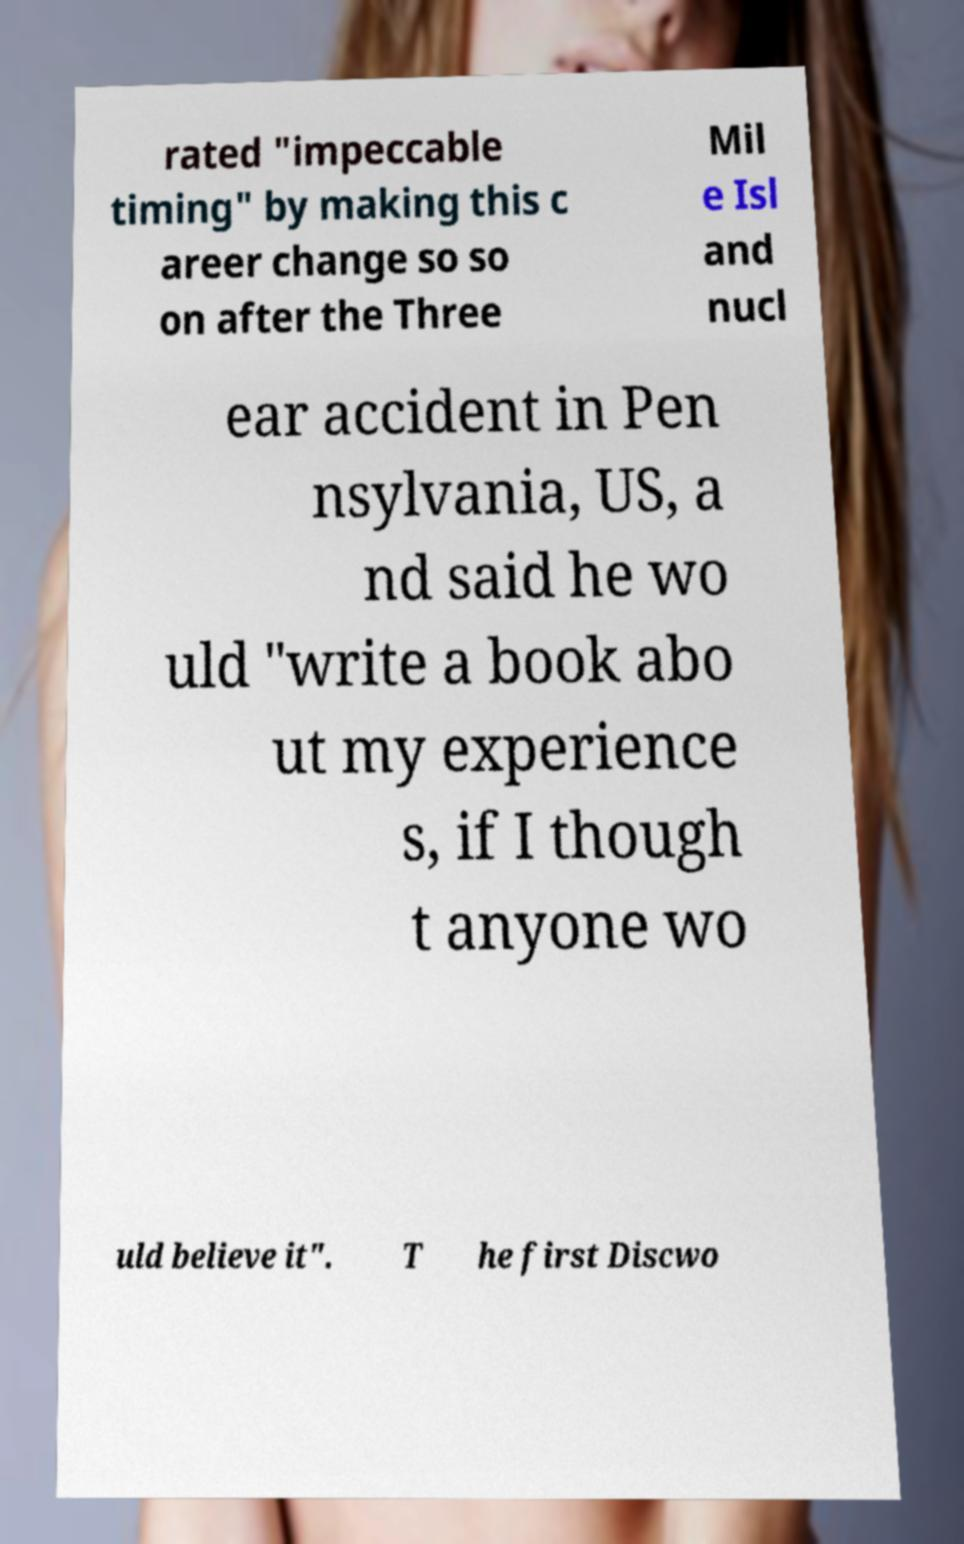Can you read and provide the text displayed in the image?This photo seems to have some interesting text. Can you extract and type it out for me? rated "impeccable timing" by making this c areer change so so on after the Three Mil e Isl and nucl ear accident in Pen nsylvania, US, a nd said he wo uld "write a book abo ut my experience s, if I though t anyone wo uld believe it". T he first Discwo 